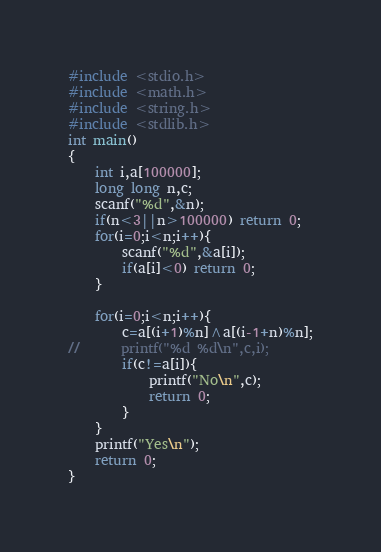<code> <loc_0><loc_0><loc_500><loc_500><_C_>#include <stdio.h>
#include <math.h>
#include <string.h>
#include <stdlib.h>
int main()
{
	int i,a[100000];
	long long n,c;
	scanf("%d",&n);
	if(n<3||n>100000) return 0;
	for(i=0;i<n;i++){
		scanf("%d",&a[i]);
		if(a[i]<0) return 0;
	}
		
	for(i=0;i<n;i++){
		c=a[(i+1)%n]^a[(i-1+n)%n];
//		printf("%d %d\n",c,i);
		if(c!=a[i]){
			printf("No\n",c);
			return 0;
		}
	}	
	printf("Yes\n");
	return 0;
}</code> 